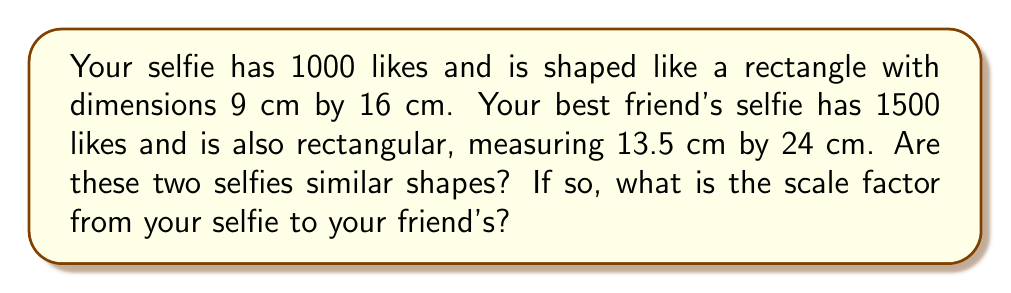What is the answer to this math problem? Let's approach this step-by-step:

1) For two rectangles to be similar, their corresponding sides must be proportional. Let's check this:

   For your selfie: $\frac{\text{length}}{\text{width}} = \frac{16}{9}$
   For your friend's selfie: $\frac{\text{length}}{\text{width}} = \frac{24}{13.5}$

2) Simplify the fraction for your friend's selfie:
   $\frac{24}{13.5} = \frac{24 \div 1.5}{13.5 \div 1.5} = \frac{16}{9}$

3) Since both ratios are equal to $\frac{16}{9}$, the rectangles are similar.

4) To find the scale factor, we can divide the length of your friend's selfie by the length of your selfie:

   Scale factor = $\frac{24}{16} = \frac{3}{2} = 1.5$

5) We can verify this with the widths:
   $\frac{13.5}{9} = \frac{3}{2} = 1.5$

Therefore, the selfies are similar with a scale factor of 1.5 from your selfie to your friend's.
Answer: Yes, scale factor 1.5 